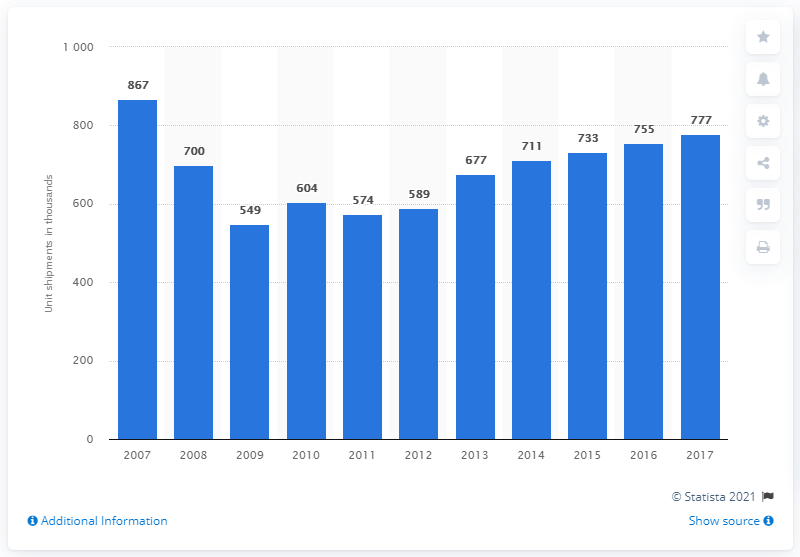Point out several critical features in this image. The forecast for electric oven unit shipments in 2017 is currently unknown. 